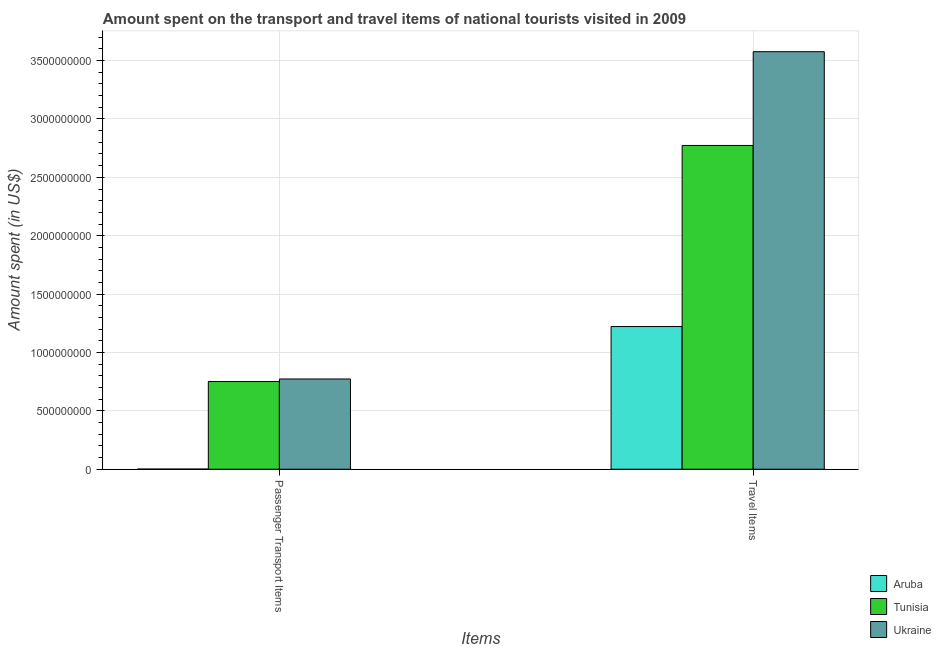How many groups of bars are there?
Your response must be concise. 2. Are the number of bars on each tick of the X-axis equal?
Make the answer very short. Yes. How many bars are there on the 2nd tick from the left?
Ensure brevity in your answer.  3. How many bars are there on the 1st tick from the right?
Make the answer very short. 3. What is the label of the 2nd group of bars from the left?
Your response must be concise. Travel Items. What is the amount spent on passenger transport items in Tunisia?
Your response must be concise. 7.51e+08. Across all countries, what is the maximum amount spent in travel items?
Your response must be concise. 3.58e+09. Across all countries, what is the minimum amount spent in travel items?
Offer a very short reply. 1.22e+09. In which country was the amount spent in travel items maximum?
Give a very brief answer. Ukraine. In which country was the amount spent on passenger transport items minimum?
Offer a terse response. Aruba. What is the total amount spent on passenger transport items in the graph?
Your answer should be very brief. 1.53e+09. What is the difference between the amount spent in travel items in Tunisia and that in Ukraine?
Give a very brief answer. -8.03e+08. What is the difference between the amount spent in travel items in Ukraine and the amount spent on passenger transport items in Tunisia?
Provide a short and direct response. 2.82e+09. What is the average amount spent in travel items per country?
Provide a short and direct response. 2.52e+09. What is the difference between the amount spent on passenger transport items and amount spent in travel items in Tunisia?
Offer a very short reply. -2.02e+09. In how many countries, is the amount spent on passenger transport items greater than 200000000 US$?
Make the answer very short. 2. What is the ratio of the amount spent on passenger transport items in Aruba to that in Tunisia?
Provide a succinct answer. 0. Is the amount spent on passenger transport items in Tunisia less than that in Ukraine?
Give a very brief answer. Yes. What does the 2nd bar from the left in Passenger Transport Items represents?
Provide a short and direct response. Tunisia. What does the 2nd bar from the right in Passenger Transport Items represents?
Ensure brevity in your answer.  Tunisia. Are all the bars in the graph horizontal?
Give a very brief answer. No. How many countries are there in the graph?
Provide a short and direct response. 3. Does the graph contain grids?
Ensure brevity in your answer.  Yes. How are the legend labels stacked?
Provide a succinct answer. Vertical. What is the title of the graph?
Provide a succinct answer. Amount spent on the transport and travel items of national tourists visited in 2009. What is the label or title of the X-axis?
Keep it short and to the point. Items. What is the label or title of the Y-axis?
Your response must be concise. Amount spent (in US$). What is the Amount spent (in US$) in Aruba in Passenger Transport Items?
Offer a very short reply. 1.20e+06. What is the Amount spent (in US$) of Tunisia in Passenger Transport Items?
Your answer should be very brief. 7.51e+08. What is the Amount spent (in US$) in Ukraine in Passenger Transport Items?
Provide a short and direct response. 7.73e+08. What is the Amount spent (in US$) in Aruba in Travel Items?
Your response must be concise. 1.22e+09. What is the Amount spent (in US$) in Tunisia in Travel Items?
Provide a succinct answer. 2.77e+09. What is the Amount spent (in US$) of Ukraine in Travel Items?
Make the answer very short. 3.58e+09. Across all Items, what is the maximum Amount spent (in US$) in Aruba?
Keep it short and to the point. 1.22e+09. Across all Items, what is the maximum Amount spent (in US$) of Tunisia?
Provide a short and direct response. 2.77e+09. Across all Items, what is the maximum Amount spent (in US$) of Ukraine?
Ensure brevity in your answer.  3.58e+09. Across all Items, what is the minimum Amount spent (in US$) of Aruba?
Provide a short and direct response. 1.20e+06. Across all Items, what is the minimum Amount spent (in US$) in Tunisia?
Provide a succinct answer. 7.51e+08. Across all Items, what is the minimum Amount spent (in US$) in Ukraine?
Keep it short and to the point. 7.73e+08. What is the total Amount spent (in US$) of Aruba in the graph?
Ensure brevity in your answer.  1.22e+09. What is the total Amount spent (in US$) of Tunisia in the graph?
Your answer should be compact. 3.52e+09. What is the total Amount spent (in US$) of Ukraine in the graph?
Offer a very short reply. 4.35e+09. What is the difference between the Amount spent (in US$) of Aruba in Passenger Transport Items and that in Travel Items?
Give a very brief answer. -1.22e+09. What is the difference between the Amount spent (in US$) of Tunisia in Passenger Transport Items and that in Travel Items?
Your response must be concise. -2.02e+09. What is the difference between the Amount spent (in US$) of Ukraine in Passenger Transport Items and that in Travel Items?
Provide a succinct answer. -2.80e+09. What is the difference between the Amount spent (in US$) in Aruba in Passenger Transport Items and the Amount spent (in US$) in Tunisia in Travel Items?
Keep it short and to the point. -2.77e+09. What is the difference between the Amount spent (in US$) in Aruba in Passenger Transport Items and the Amount spent (in US$) in Ukraine in Travel Items?
Keep it short and to the point. -3.57e+09. What is the difference between the Amount spent (in US$) of Tunisia in Passenger Transport Items and the Amount spent (in US$) of Ukraine in Travel Items?
Offer a terse response. -2.82e+09. What is the average Amount spent (in US$) in Aruba per Items?
Your answer should be compact. 6.12e+08. What is the average Amount spent (in US$) of Tunisia per Items?
Your response must be concise. 1.76e+09. What is the average Amount spent (in US$) in Ukraine per Items?
Your answer should be compact. 2.17e+09. What is the difference between the Amount spent (in US$) in Aruba and Amount spent (in US$) in Tunisia in Passenger Transport Items?
Make the answer very short. -7.50e+08. What is the difference between the Amount spent (in US$) in Aruba and Amount spent (in US$) in Ukraine in Passenger Transport Items?
Provide a succinct answer. -7.72e+08. What is the difference between the Amount spent (in US$) of Tunisia and Amount spent (in US$) of Ukraine in Passenger Transport Items?
Make the answer very short. -2.20e+07. What is the difference between the Amount spent (in US$) of Aruba and Amount spent (in US$) of Tunisia in Travel Items?
Your answer should be compact. -1.55e+09. What is the difference between the Amount spent (in US$) in Aruba and Amount spent (in US$) in Ukraine in Travel Items?
Provide a short and direct response. -2.35e+09. What is the difference between the Amount spent (in US$) of Tunisia and Amount spent (in US$) of Ukraine in Travel Items?
Provide a succinct answer. -8.03e+08. What is the ratio of the Amount spent (in US$) in Tunisia in Passenger Transport Items to that in Travel Items?
Provide a short and direct response. 0.27. What is the ratio of the Amount spent (in US$) in Ukraine in Passenger Transport Items to that in Travel Items?
Your response must be concise. 0.22. What is the difference between the highest and the second highest Amount spent (in US$) of Aruba?
Offer a very short reply. 1.22e+09. What is the difference between the highest and the second highest Amount spent (in US$) in Tunisia?
Offer a very short reply. 2.02e+09. What is the difference between the highest and the second highest Amount spent (in US$) in Ukraine?
Make the answer very short. 2.80e+09. What is the difference between the highest and the lowest Amount spent (in US$) of Aruba?
Ensure brevity in your answer.  1.22e+09. What is the difference between the highest and the lowest Amount spent (in US$) of Tunisia?
Your response must be concise. 2.02e+09. What is the difference between the highest and the lowest Amount spent (in US$) in Ukraine?
Provide a succinct answer. 2.80e+09. 